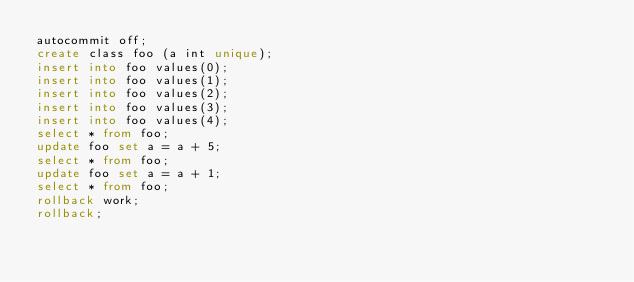Convert code to text. <code><loc_0><loc_0><loc_500><loc_500><_SQL_>autocommit off;
create class foo (a int unique);
insert into foo values(0);
insert into foo values(1);
insert into foo values(2);
insert into foo values(3);
insert into foo values(4);
select * from foo;
update foo set a = a + 5;
select * from foo;
update foo set a = a + 1;
select * from foo;
rollback work;
rollback;
</code> 